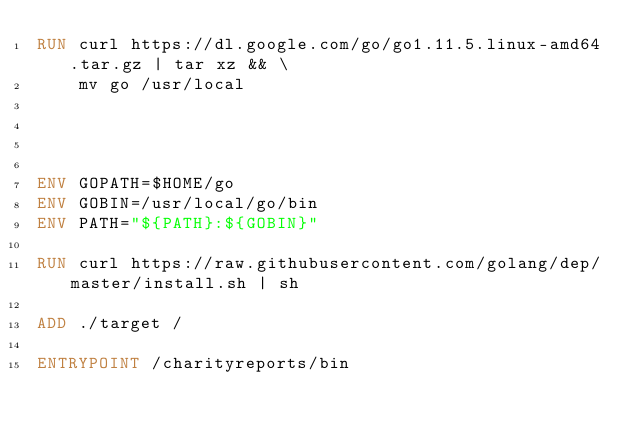Convert code to text. <code><loc_0><loc_0><loc_500><loc_500><_Dockerfile_>RUN curl https://dl.google.com/go/go1.11.5.linux-amd64.tar.gz | tar xz && \
    mv go /usr/local




ENV GOPATH=$HOME/go
ENV GOBIN=/usr/local/go/bin
ENV PATH="${PATH}:${GOBIN}"

RUN curl https://raw.githubusercontent.com/golang/dep/master/install.sh | sh

ADD ./target /

ENTRYPOINT /charityreports/bin</code> 